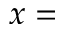<formula> <loc_0><loc_0><loc_500><loc_500>x =</formula> 